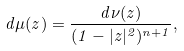<formula> <loc_0><loc_0><loc_500><loc_500>d \mu ( z ) = \frac { d \nu ( z ) } { ( 1 - | z | ^ { 2 } ) ^ { n + 1 } } ,</formula> 